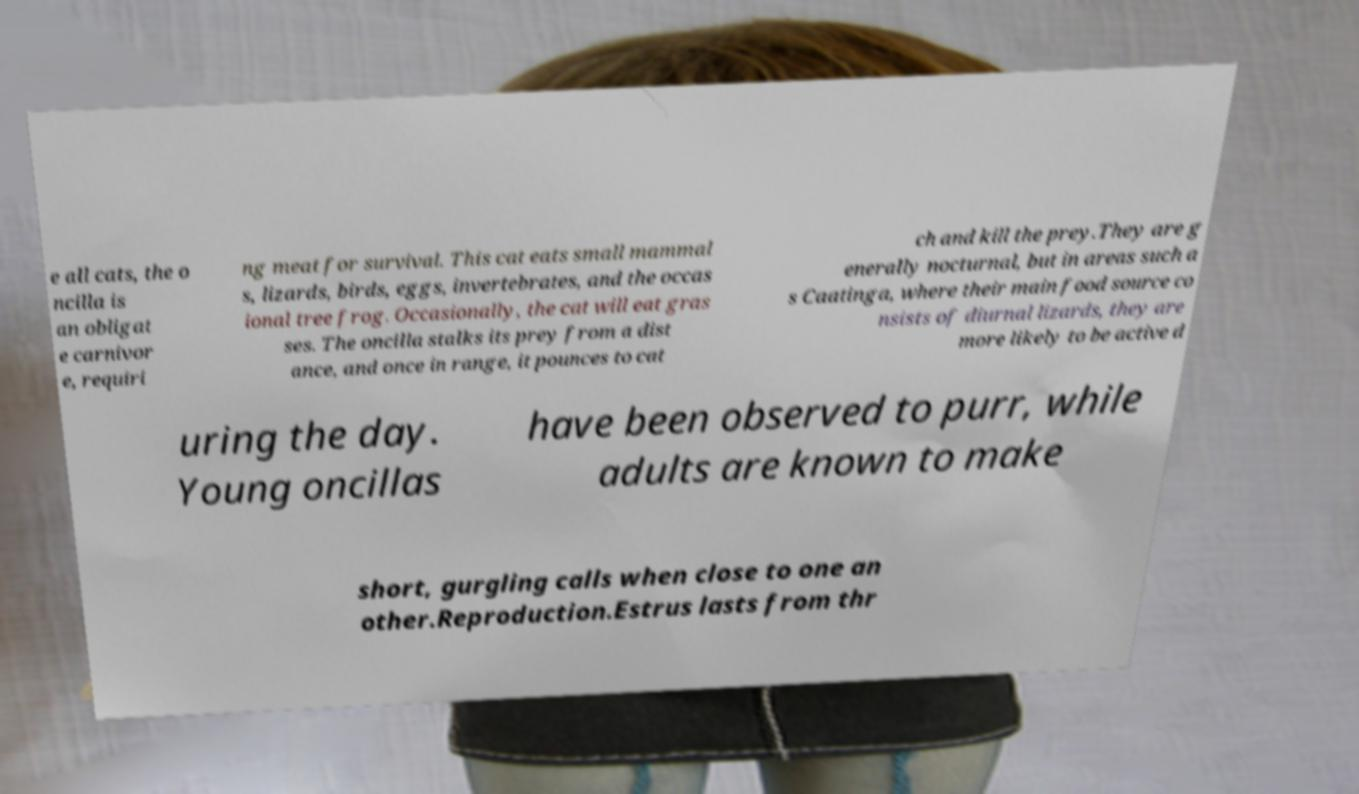Could you assist in decoding the text presented in this image and type it out clearly? e all cats, the o ncilla is an obligat e carnivor e, requiri ng meat for survival. This cat eats small mammal s, lizards, birds, eggs, invertebrates, and the occas ional tree frog. Occasionally, the cat will eat gras ses. The oncilla stalks its prey from a dist ance, and once in range, it pounces to cat ch and kill the prey.They are g enerally nocturnal, but in areas such a s Caatinga, where their main food source co nsists of diurnal lizards, they are more likely to be active d uring the day. Young oncillas have been observed to purr, while adults are known to make short, gurgling calls when close to one an other.Reproduction.Estrus lasts from thr 